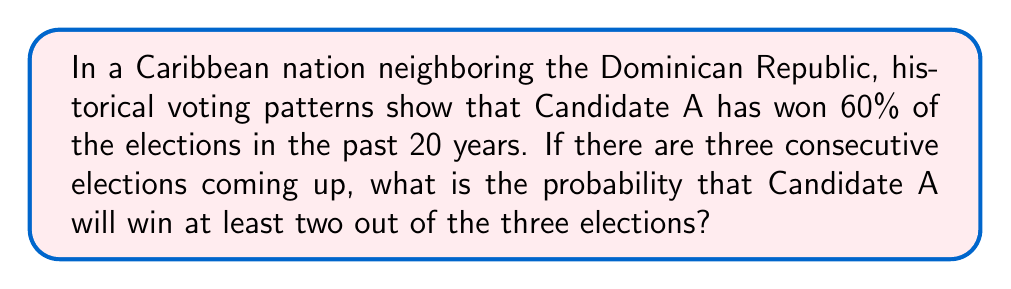Can you answer this question? Let's approach this step-by-step:

1) First, we need to understand what the question is asking. We're looking for the probability of Candidate A winning at least 2 out of 3 elections.

2) We know from historical data that Candidate A has a 60% chance of winning any single election. Let's define this as $p = 0.6$.

3) Now, we need to consider the possible scenarios where Candidate A wins at least 2 out of 3 elections:
   - Candidate A wins all 3 elections
   - Candidate A wins exactly 2 out of 3 elections

4) Let's calculate the probability of each scenario:

   a) Probability of winning all 3 elections:
      $$P(\text{3 wins}) = p^3 = 0.6^3 = 0.216$$

   b) Probability of winning exactly 2 out of 3 elections:
      There are 3 ways this can happen: WWL, WLW, LWW (where W = win, L = lose)
      $$P(\text{2 wins}) = \binom{3}{2} \cdot p^2 \cdot (1-p) = 3 \cdot 0.6^2 \cdot 0.4 = 0.432$$

5) The total probability is the sum of these two probabilities:
   $$P(\text{at least 2 wins}) = P(\text{3 wins}) + P(\text{2 wins}) = 0.216 + 0.432 = 0.648$$

6) Therefore, the probability of Candidate A winning at least 2 out of 3 elections is 0.648 or 64.8%.
Answer: 0.648 or 64.8% 